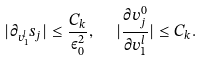<formula> <loc_0><loc_0><loc_500><loc_500>| \partial _ { v _ { 1 } ^ { l } } s _ { j } | \leq \frac { C _ { k } } { \varepsilon _ { 0 } ^ { 2 } } , \text { \ \ } | \frac { \partial v _ { j } ^ { 0 } } { \partial v _ { 1 } ^ { l } } | \leq C _ { k } .</formula> 